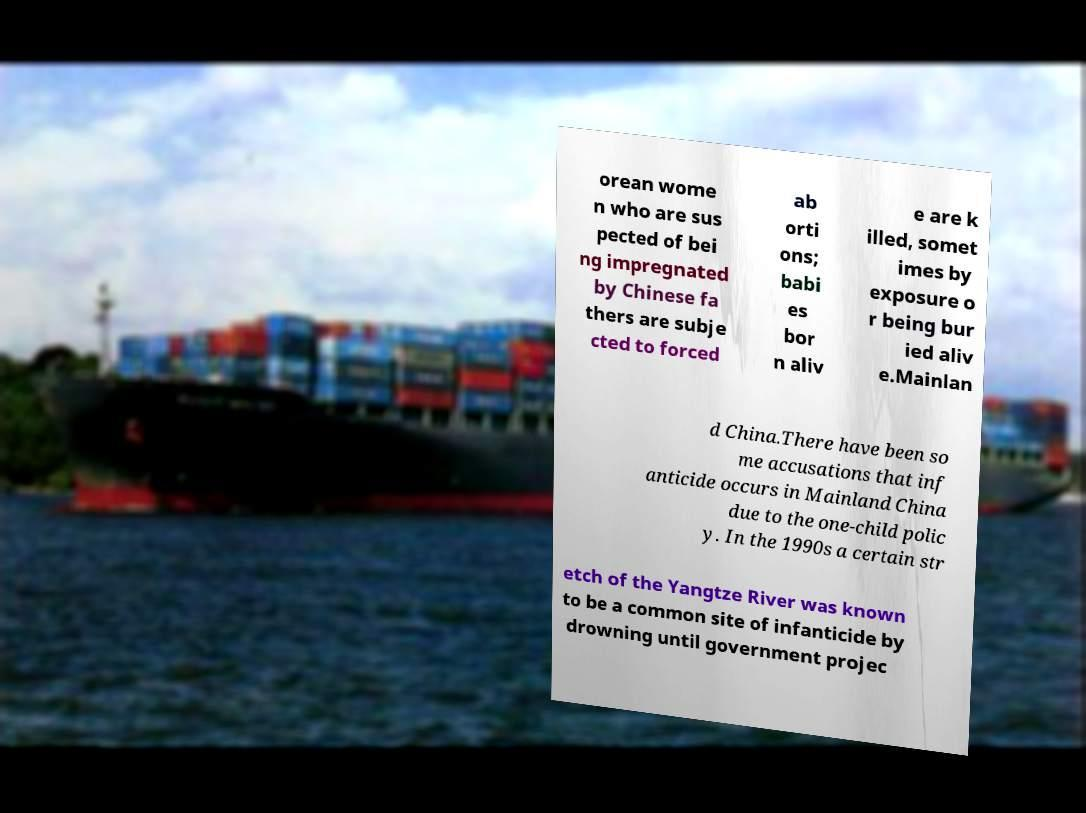Could you extract and type out the text from this image? orean wome n who are sus pected of bei ng impregnated by Chinese fa thers are subje cted to forced ab orti ons; babi es bor n aliv e are k illed, somet imes by exposure o r being bur ied aliv e.Mainlan d China.There have been so me accusations that inf anticide occurs in Mainland China due to the one-child polic y. In the 1990s a certain str etch of the Yangtze River was known to be a common site of infanticide by drowning until government projec 